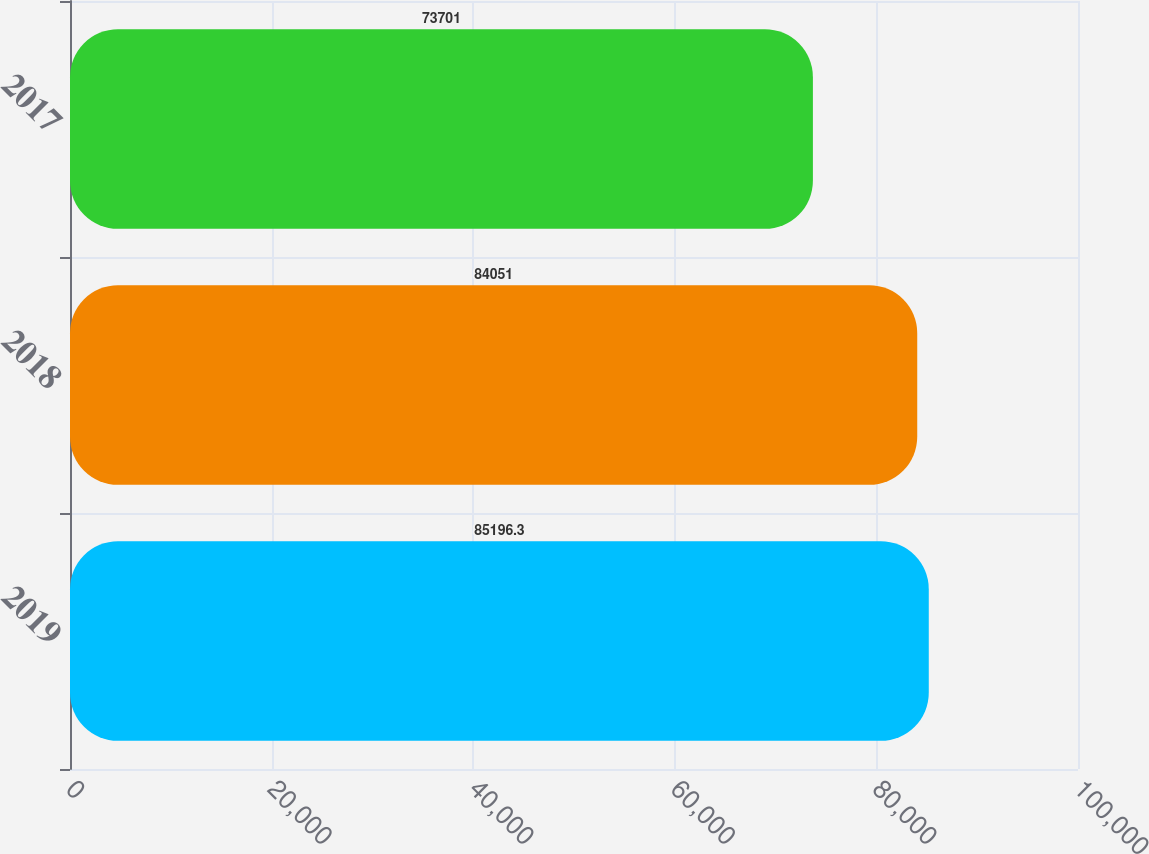<chart> <loc_0><loc_0><loc_500><loc_500><bar_chart><fcel>2019<fcel>2018<fcel>2017<nl><fcel>85196.3<fcel>84051<fcel>73701<nl></chart> 